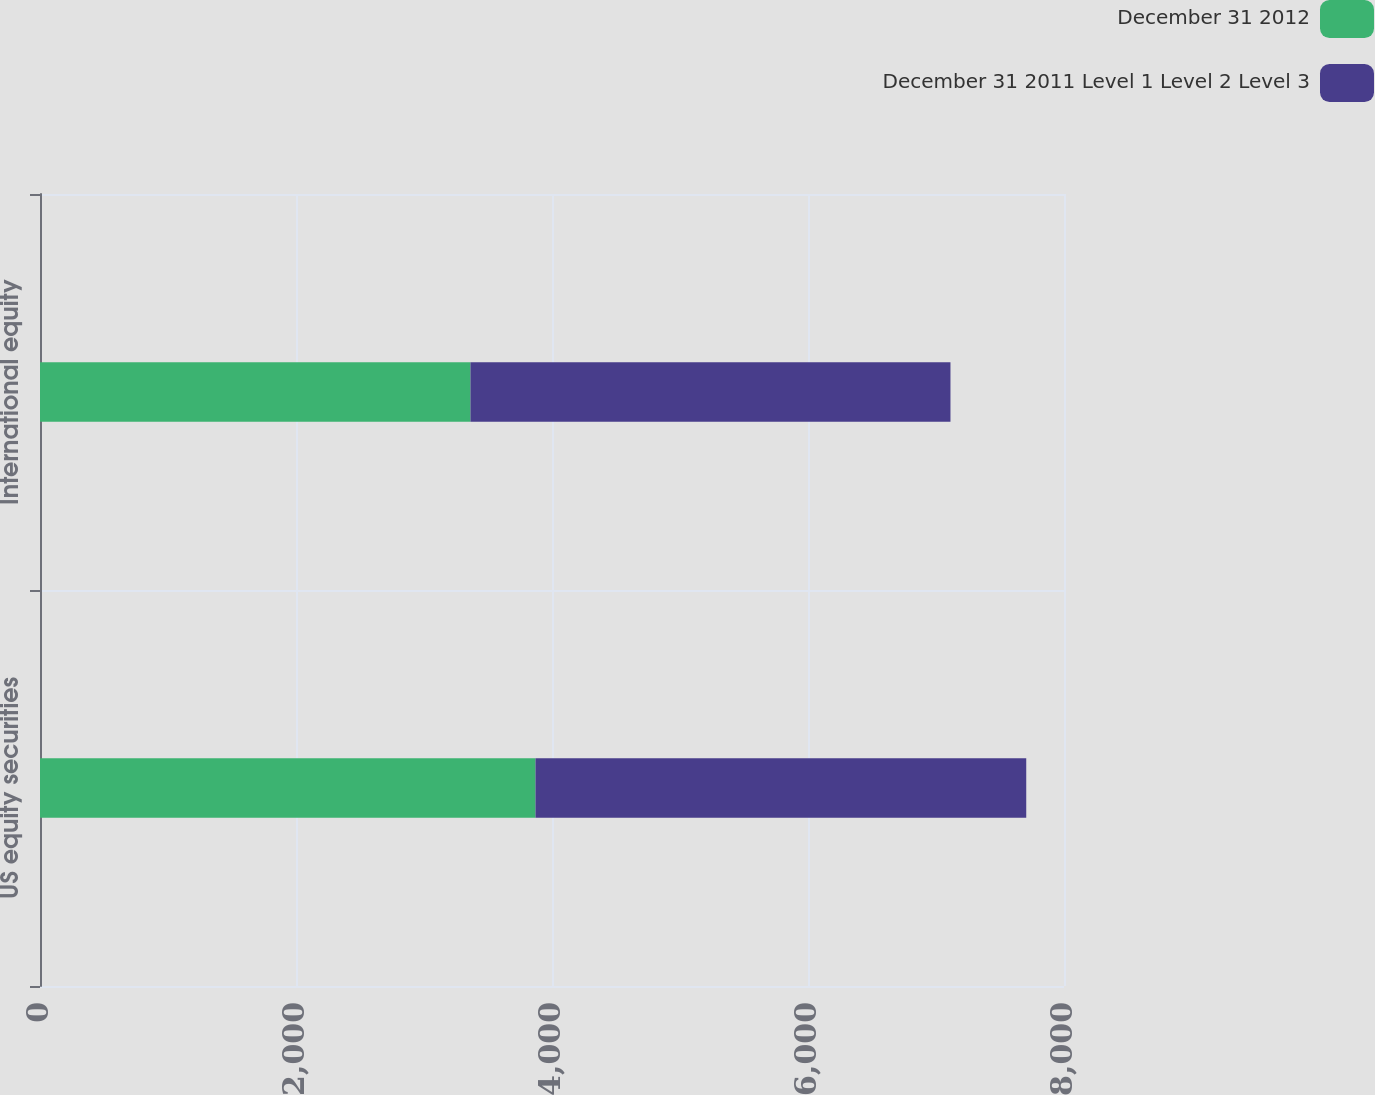Convert chart to OTSL. <chart><loc_0><loc_0><loc_500><loc_500><stacked_bar_chart><ecel><fcel>US equity securities<fcel>International equity<nl><fcel>December 31 2012<fcel>3871<fcel>3363<nl><fcel>December 31 2011 Level 1 Level 2 Level 3<fcel>3834<fcel>3750<nl></chart> 